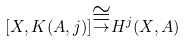Convert formula to latex. <formula><loc_0><loc_0><loc_500><loc_500>[ X , K ( A , j ) ] { \stackrel { \cong } { \to } } H ^ { j } ( X , A )</formula> 